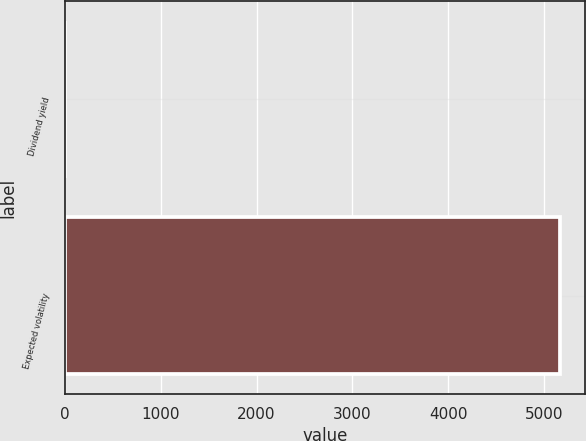Convert chart. <chart><loc_0><loc_0><loc_500><loc_500><bar_chart><fcel>Dividend yield<fcel>Expected volatility<nl><fcel>3.23<fcel>5165<nl></chart> 